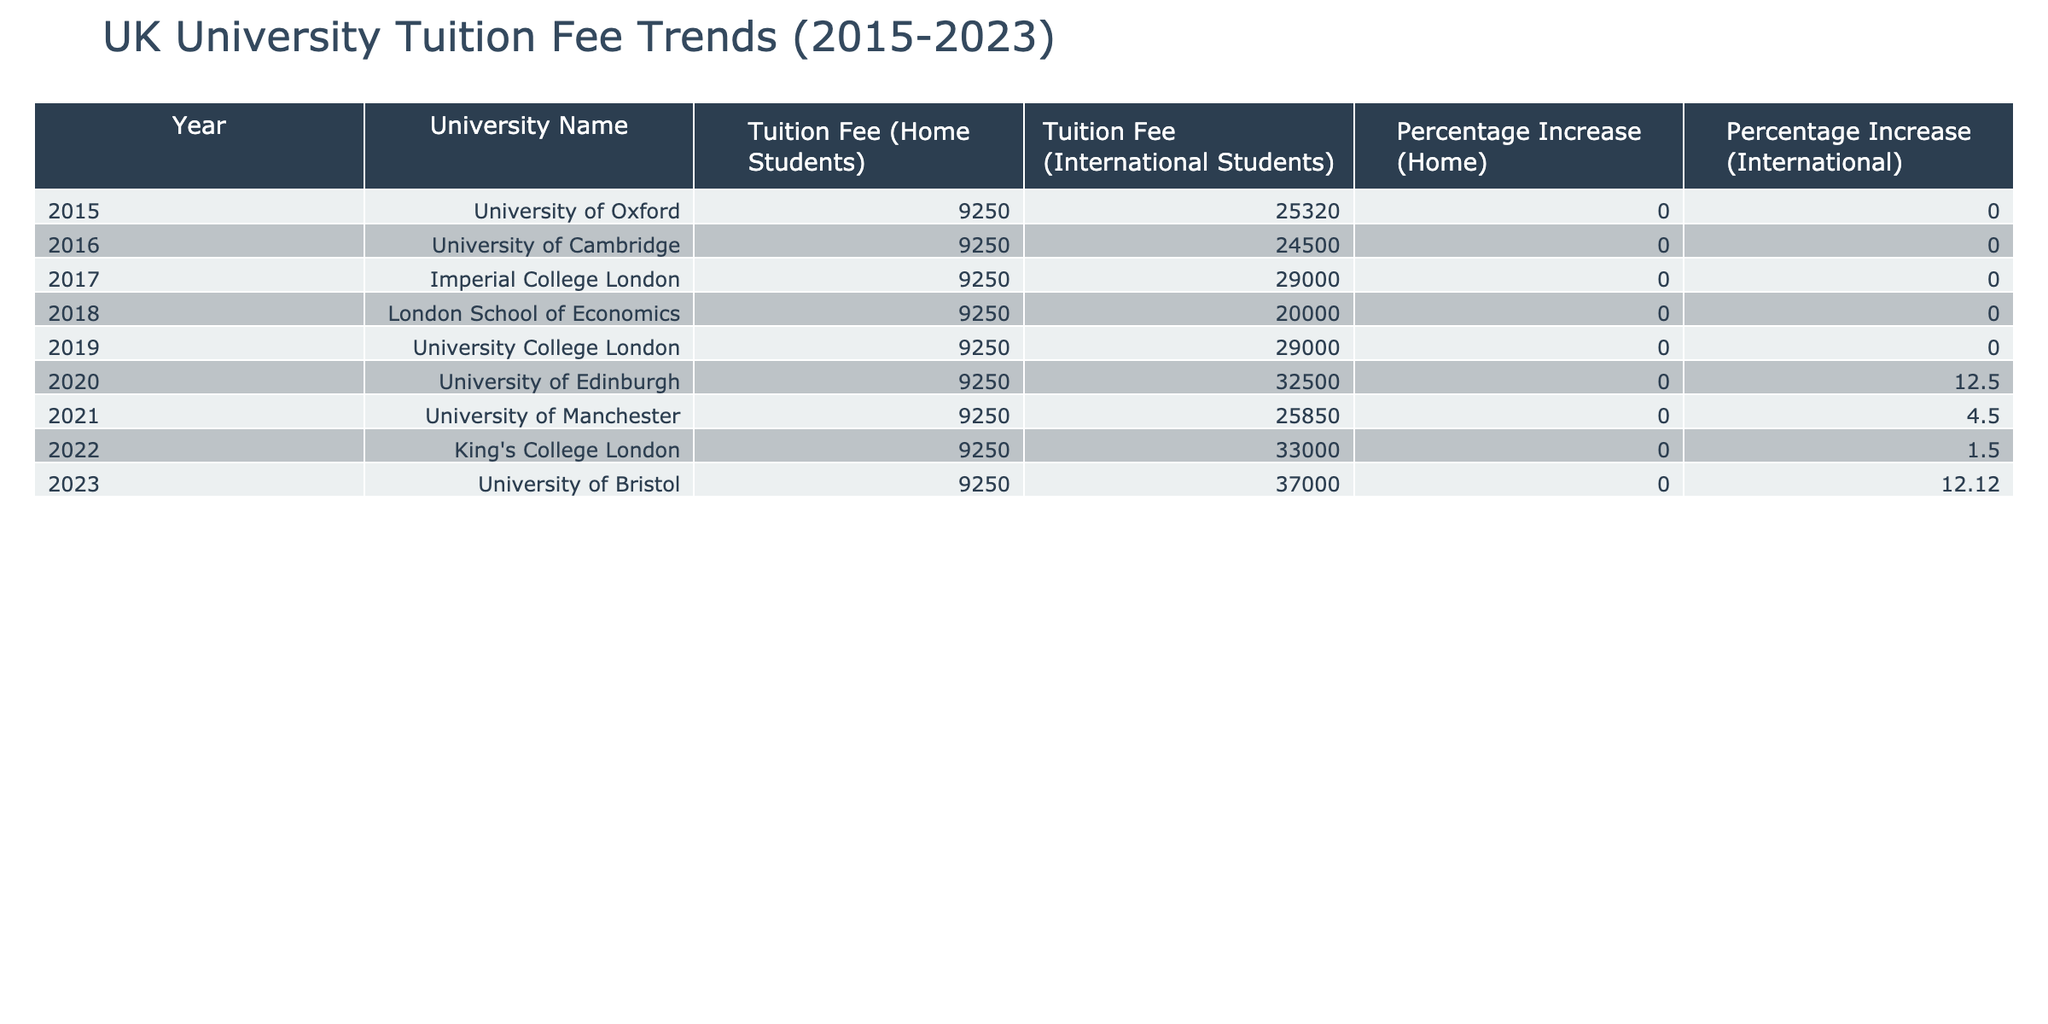What was the tuition fee for home students at the University of Oxford in 2015? Referring to the table, the tuition fee listed for home students at the University of Oxford in 2015 is £9,250.
Answer: £9,250 Which university had the highest tuition fee for international students in 2023? The table shows that in 2023, the University of Bristol had the highest tuition fee for international students at £37,000.
Answer: University of Bristol What is the percentage increase in tuition fees for international students from 2020 to 2023? The tuition fee for international students in 2020 is £32,500 and in 2023 it is £37,000. The increase is £37,000 - £32,500 = £4,500. To find the percentage increase, divide the increase by the original price: (£4,500 / £32,500) * 100 = 13.85% (rounded).
Answer: 13.85% Was there any increase in tuition fees for home students between 2015 and 2023? From observing the table, the tuition fees for home students remained constant at £9,250 from 2015 to 2023, indicating no increase.
Answer: No What is the average tuition fee for international students across all universities in 2015 and 2022? The tuition fees for international students in 2015 are £25,320 (Oxford) and in 2022 are £33,000 (King's College London). To find the average, add these values: (£25,320 + £33,000) = £58,320 and divide by 2, which gives £29,160.
Answer: £29,160 What was the percentage increase for international students at the University of Edinburgh from 2020 to 2021? In 2020, the percentage increase for international students at the University of Edinburgh is listed as 12.5%, while for 2021 at the University of Manchester it is 4.5%. The question concerns the University of Edinburgh, which did not show a specified increase in 2021, thus indicating it stayed the same overall.
Answer: No increase specified Which university experienced a consistent tuition fee for home students from 2015 to 2023? A review of the table shows that all entries for home students remain at £9,250 for each year from 2015 through 2023; thus, it can be concluded that no university changed this fee.
Answer: All universities How much more expensive was the tuition for international students at King's College London compared to the University of Manchester in 2021? The tuition fees for international students in 2021 are £25,850 at the University of Manchester and £33,000 at King's College London. The difference is calculated as £33,000 - £25,850 = £7,150.
Answer: £7,150 